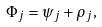<formula> <loc_0><loc_0><loc_500><loc_500>\Phi _ { j } = \psi _ { j } + \rho _ { j } ,</formula> 